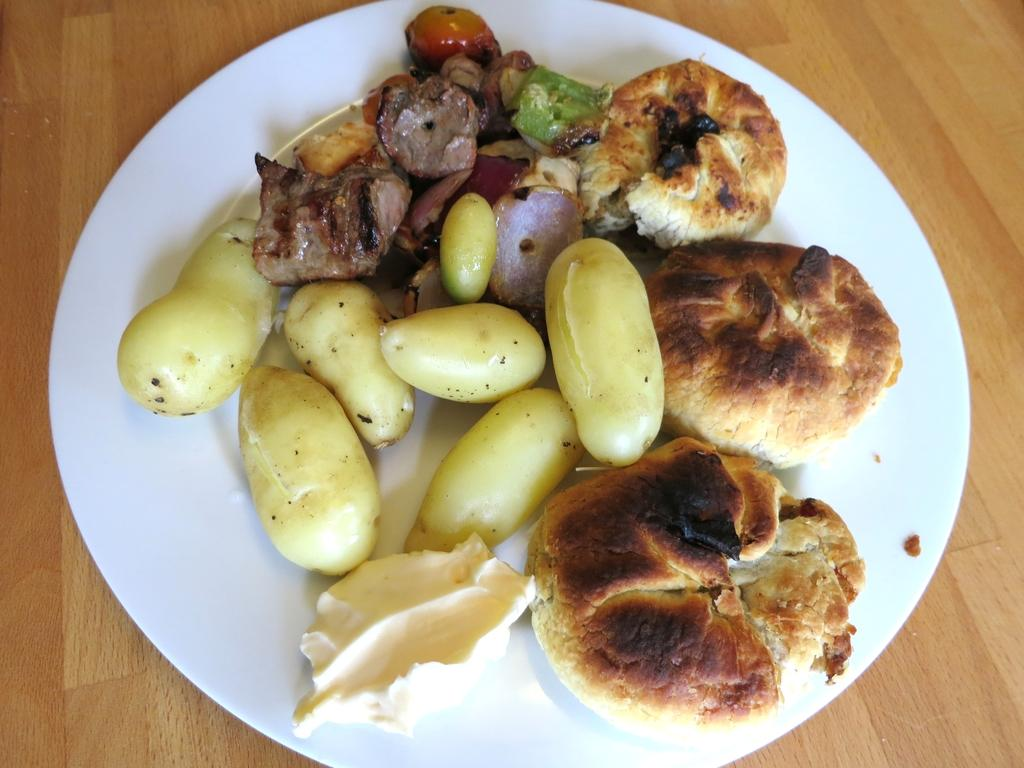What type of food can be seen in the image? There is food in the image, but the specific type is not mentioned. What kind of vegetables are present in the image? There are vegetables in the image, but the specific type is not mentioned. How are the food and vegetables arranged in the image? The food and vegetables are placed in a plate in the image. On what surface is the plate kept in the image? The plate is kept on a surface in the image. What is the name of the goldfish swimming in the image? There is no goldfish present in the image. How does the downtown area look in the image? The image does not depict a downtown area. 